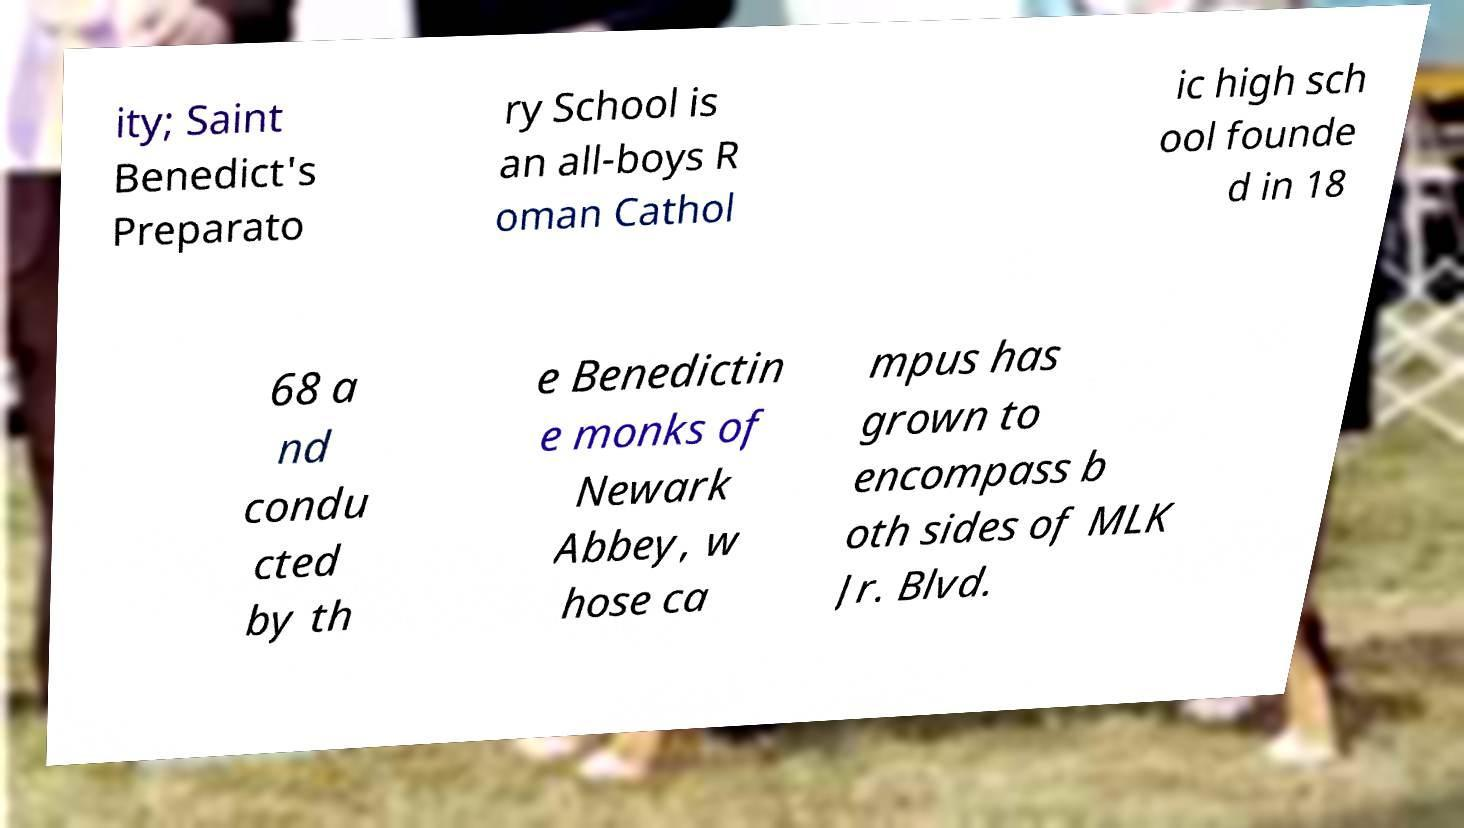Could you extract and type out the text from this image? ity; Saint Benedict's Preparato ry School is an all-boys R oman Cathol ic high sch ool founde d in 18 68 a nd condu cted by th e Benedictin e monks of Newark Abbey, w hose ca mpus has grown to encompass b oth sides of MLK Jr. Blvd. 